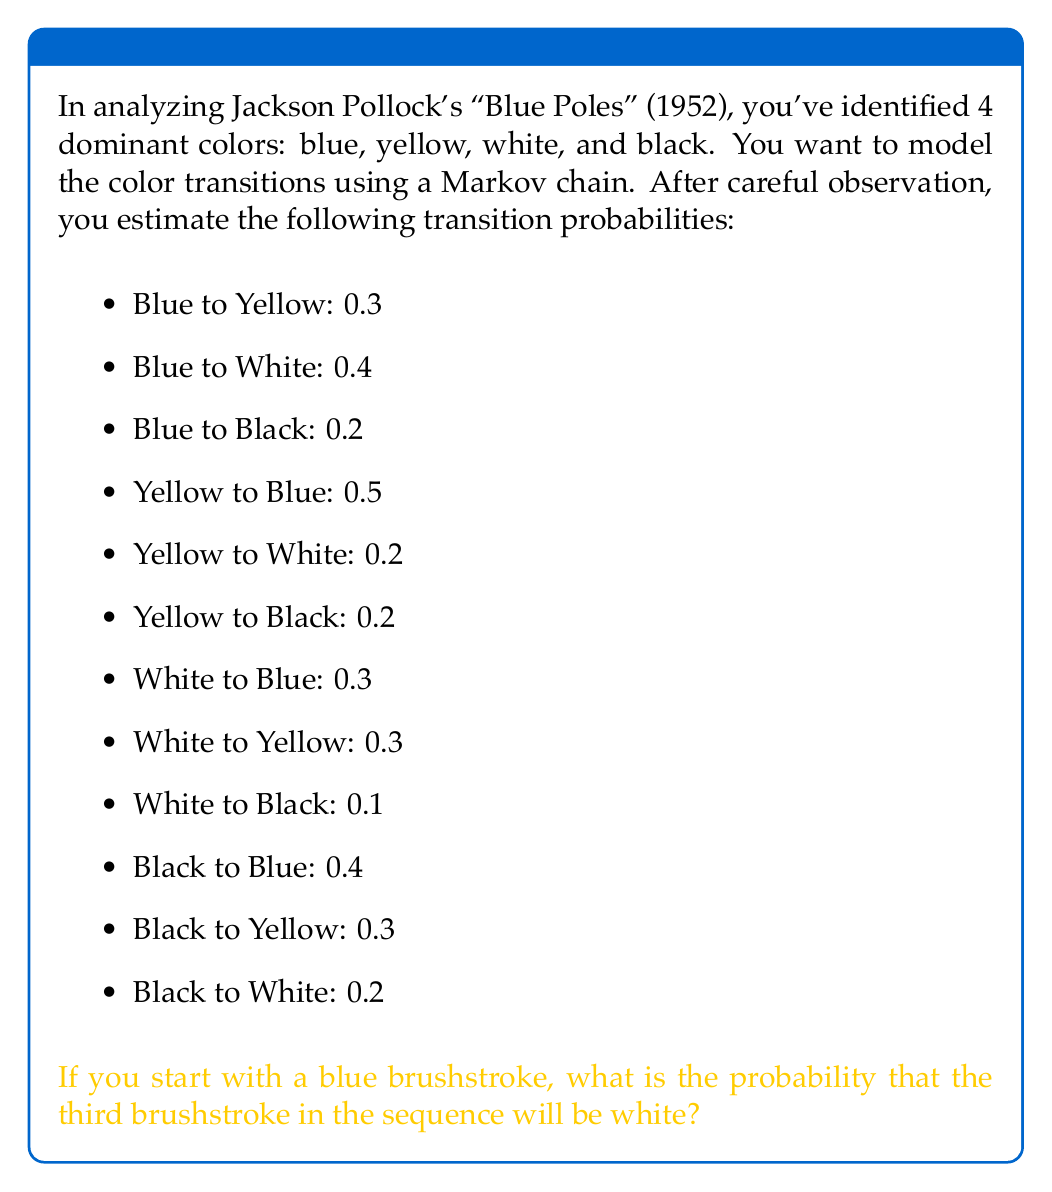Show me your answer to this math problem. To solve this problem, we need to use the properties of Markov chains and matrix multiplication. Let's approach this step-by-step:

1) First, let's create the transition matrix P based on the given probabilities. The rows and columns will be ordered as Blue (B), Yellow (Y), White (W), Black (Bl).

   $$P = \begin{bmatrix}
   0.1 & 0.3 & 0.4 & 0.2 \\
   0.5 & 0.1 & 0.2 & 0.2 \\
   0.3 & 0.3 & 0.3 & 0.1 \\
   0.4 & 0.3 & 0.2 & 0.1
   \end{bmatrix}$$

2) We start with blue, so our initial state vector is:

   $$v_0 = \begin{bmatrix} 1 & 0 & 0 & 0 \end{bmatrix}$$

3) To find the probability distribution after one step, we multiply $v_0$ by P:

   $$v_1 = v_0P = \begin{bmatrix} 0.1 & 0.3 & 0.4 & 0.2 \end{bmatrix}$$

4) To find the probability distribution after two steps, we multiply $v_1$ by P again:

   $$v_2 = v_1P = \begin{bmatrix} 0.1 & 0.3 & 0.4 & 0.2 \end{bmatrix} \begin{bmatrix}
   0.1 & 0.3 & 0.4 & 0.2 \\
   0.5 & 0.1 & 0.2 & 0.2 \\
   0.3 & 0.3 & 0.3 & 0.1 \\
   0.4 & 0.3 & 0.2 & 0.1
   \end{bmatrix}$$

5) Performing this matrix multiplication:

   $$v_2 = \begin{bmatrix} 0.34 & 0.25 & 0.28 & 0.13 \end{bmatrix}$$

6) The probability that the third brushstroke is white is the third element of $v_2$, which is 0.28 or 28%.
Answer: 0.28 